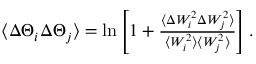<formula> <loc_0><loc_0><loc_500><loc_500>\begin{array} { r } { \langle \Delta \Theta _ { i } \Delta \Theta _ { j } \rangle = \ln \left [ 1 + \frac { \langle \Delta W _ { i } ^ { 2 } \Delta W _ { j } ^ { 2 } \rangle } { \langle W _ { i } ^ { 2 } \rangle \langle W _ { j } ^ { 2 } \rangle } \right ] . } \end{array}</formula> 